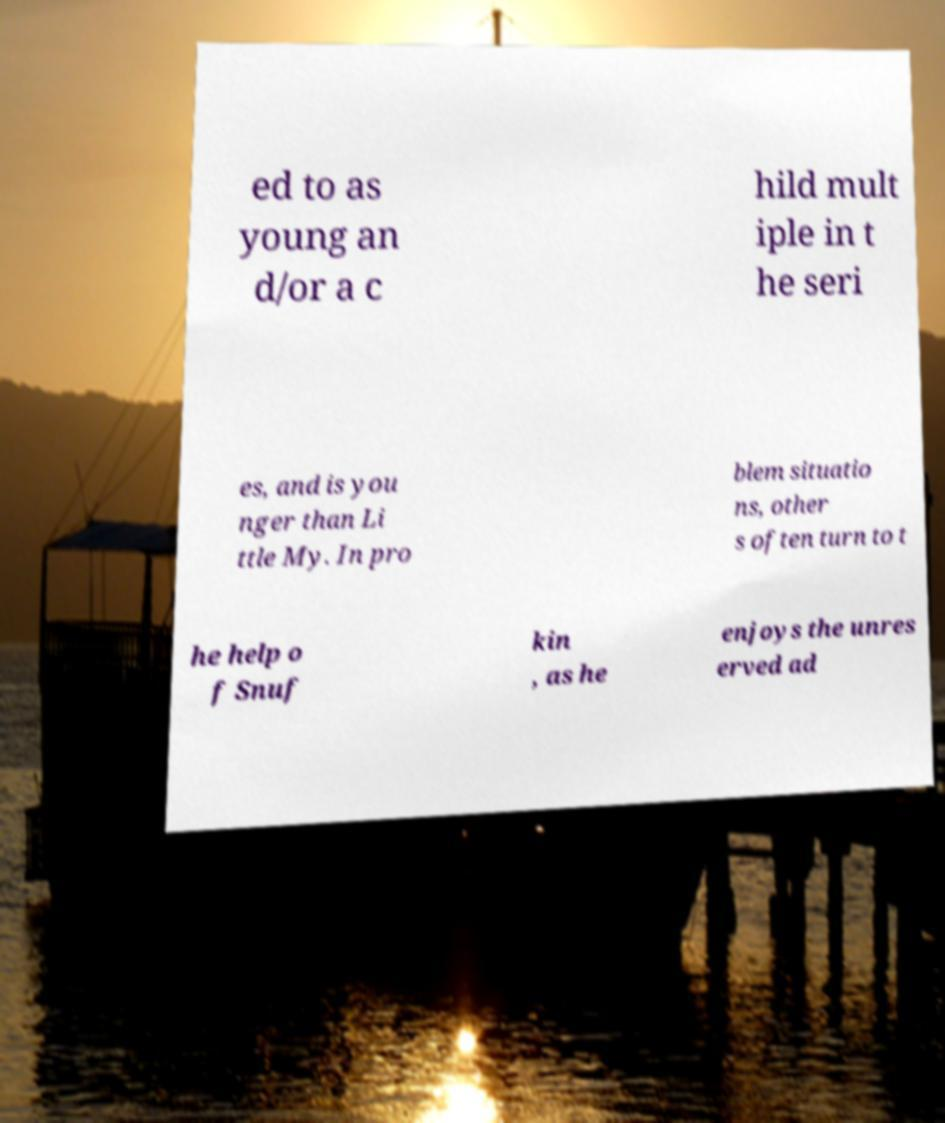There's text embedded in this image that I need extracted. Can you transcribe it verbatim? ed to as young an d/or a c hild mult iple in t he seri es, and is you nger than Li ttle My. In pro blem situatio ns, other s often turn to t he help o f Snuf kin , as he enjoys the unres erved ad 